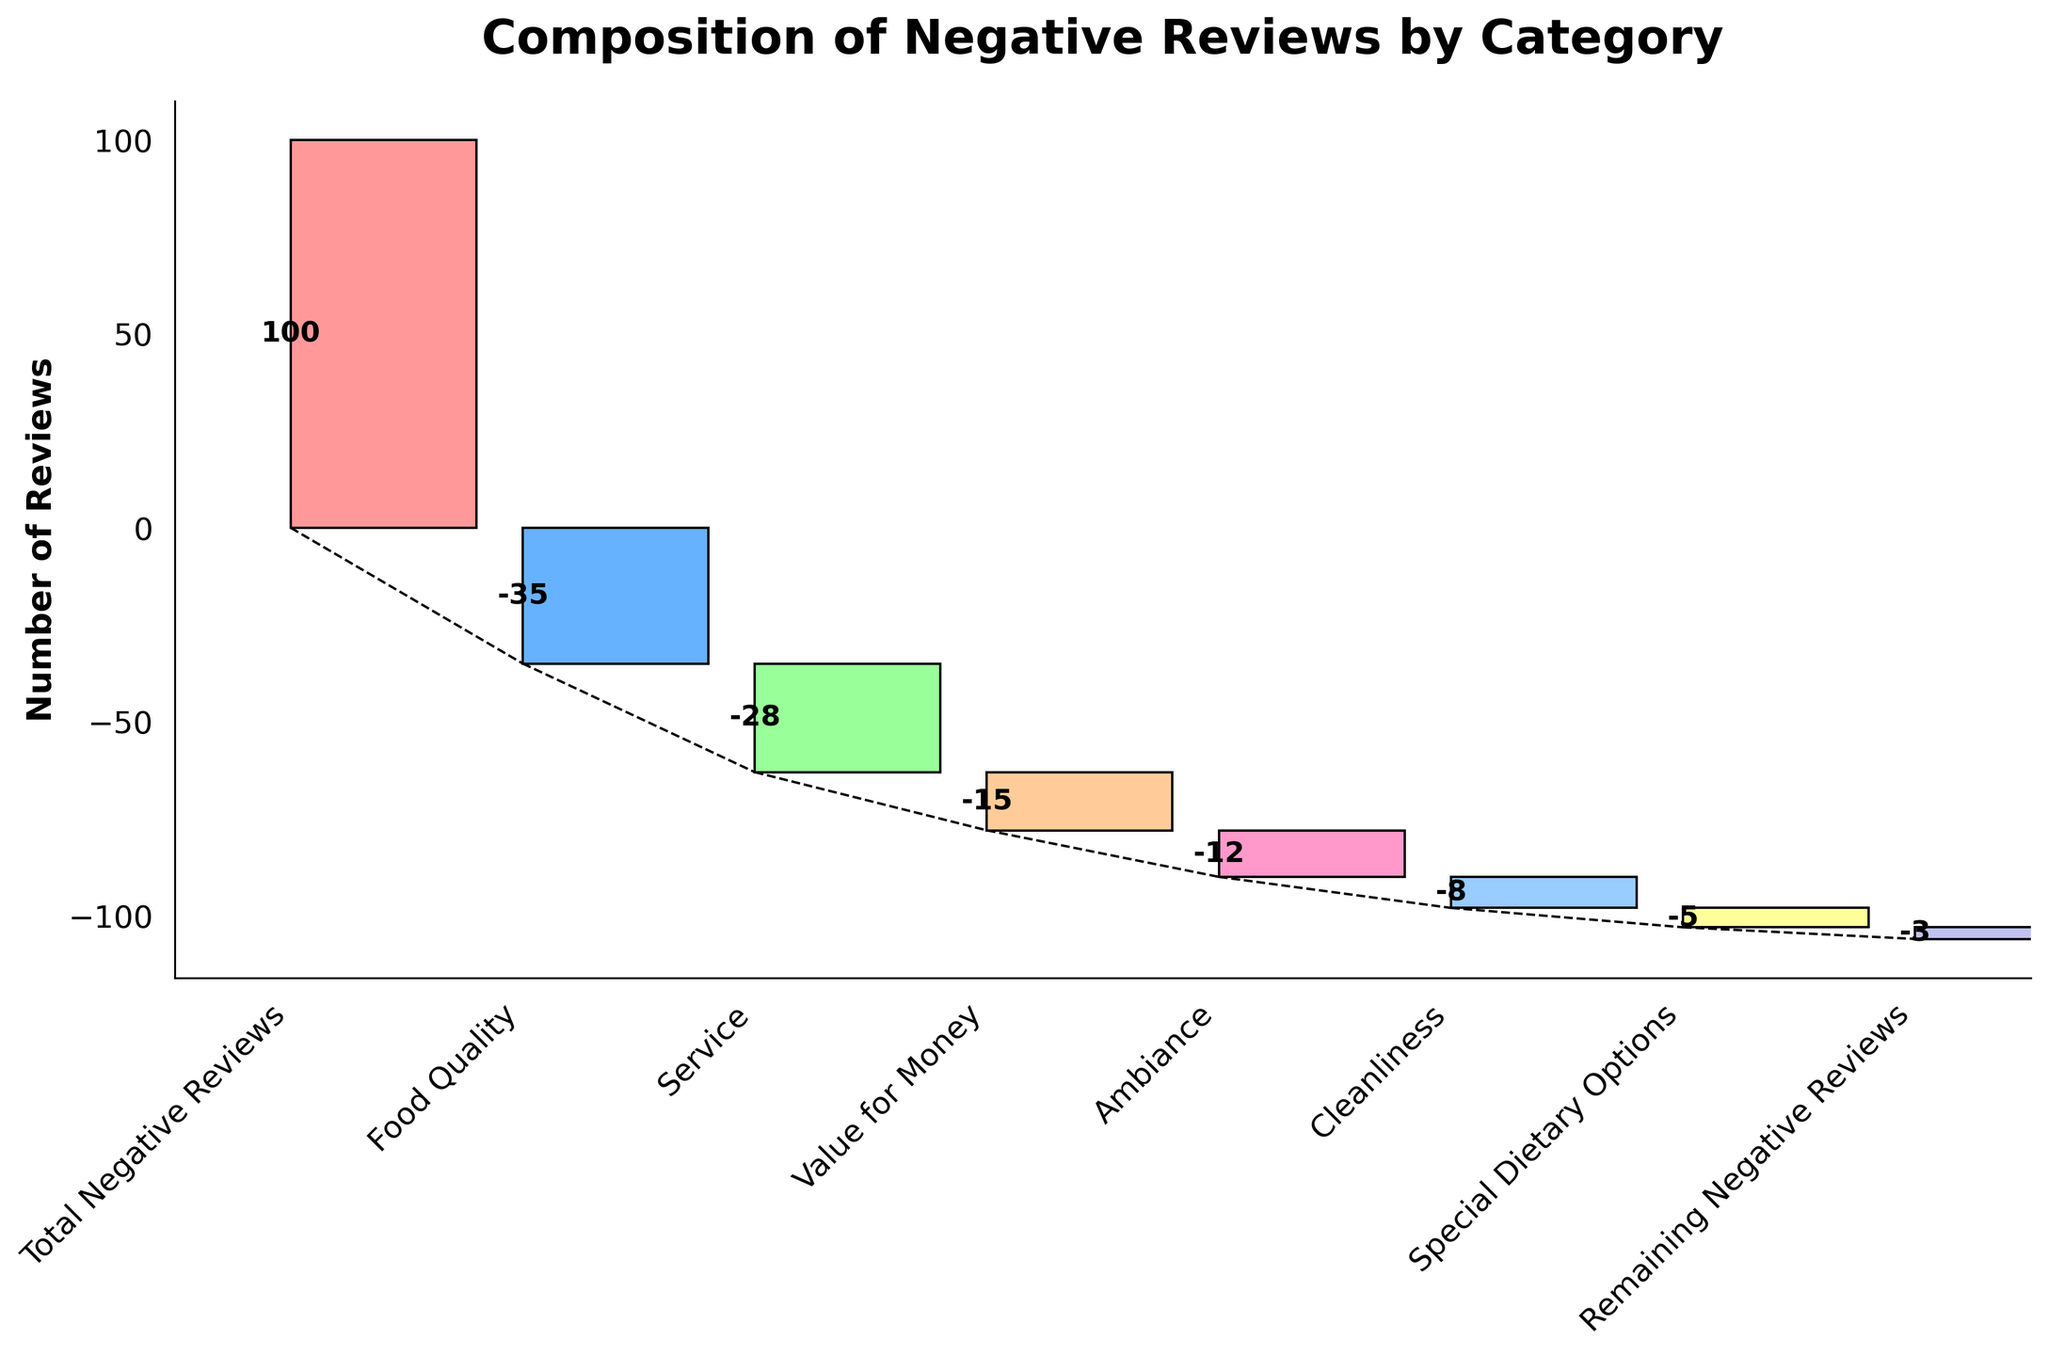what's the title of the figure? The title is usually given at the top of the figure. In this case, it's mentioned at the top in a bold large font.
Answer: Composition of Negative Reviews by Category what's the total number of negative reviews? The total number of negative reviews is usually represented by the first bar in the waterfall chart, labeled as "Total Negative Reviews" and showing the numeric value on the bar.
Answer: 100 which category has the highest number of negative reviews? Look at the heights of the bars representing the individual categories—Food Quality, Service, Value for Money, etc.—and identify the one with the tallest bar (most negative reviews).
Answer: Food Quality what's the difference in negative reviews between Food Quality and Service? Look at the numeric values for Food Quality and Service (35 and 28 respectively), and subtract the smaller from the larger.
Answer: 7 what's the combined total of negative reviews from Ambiance and Cleanliness? Look at the individual values of Ambiance and Cleanliness (12 and 8 respectively), and sum them up.
Answer: 20 how many categories are being evaluated for negative reviews? Count the number of different bars representing distinct categories, excluding the "Total Negative Reviews" bar.
Answer: 6 what's the second largest contributor to negative reviews? Observe the heights/values of the bars for each category and identify the one with the second-highest value.
Answer: Service which category has the least number of negative reviews? Identify the bar with the smallest negative value among all the categories listed.
Answer: Remaining Negative Reviews what percentage of the total negative reviews is due to Food Quality? Divide the Food Quality value by the Total Negative Reviews value and multiply by 100 to get the percentage. 35 / 100 * 100 = 35%
Answer: 35% what is the difference between the categories with the most and the least negative reviews? Identify the largest (Food Quality, 35) and the smallest (Remaining Negative Reviews, 3) and subtract the smallest from the largest.
Answer: 32 